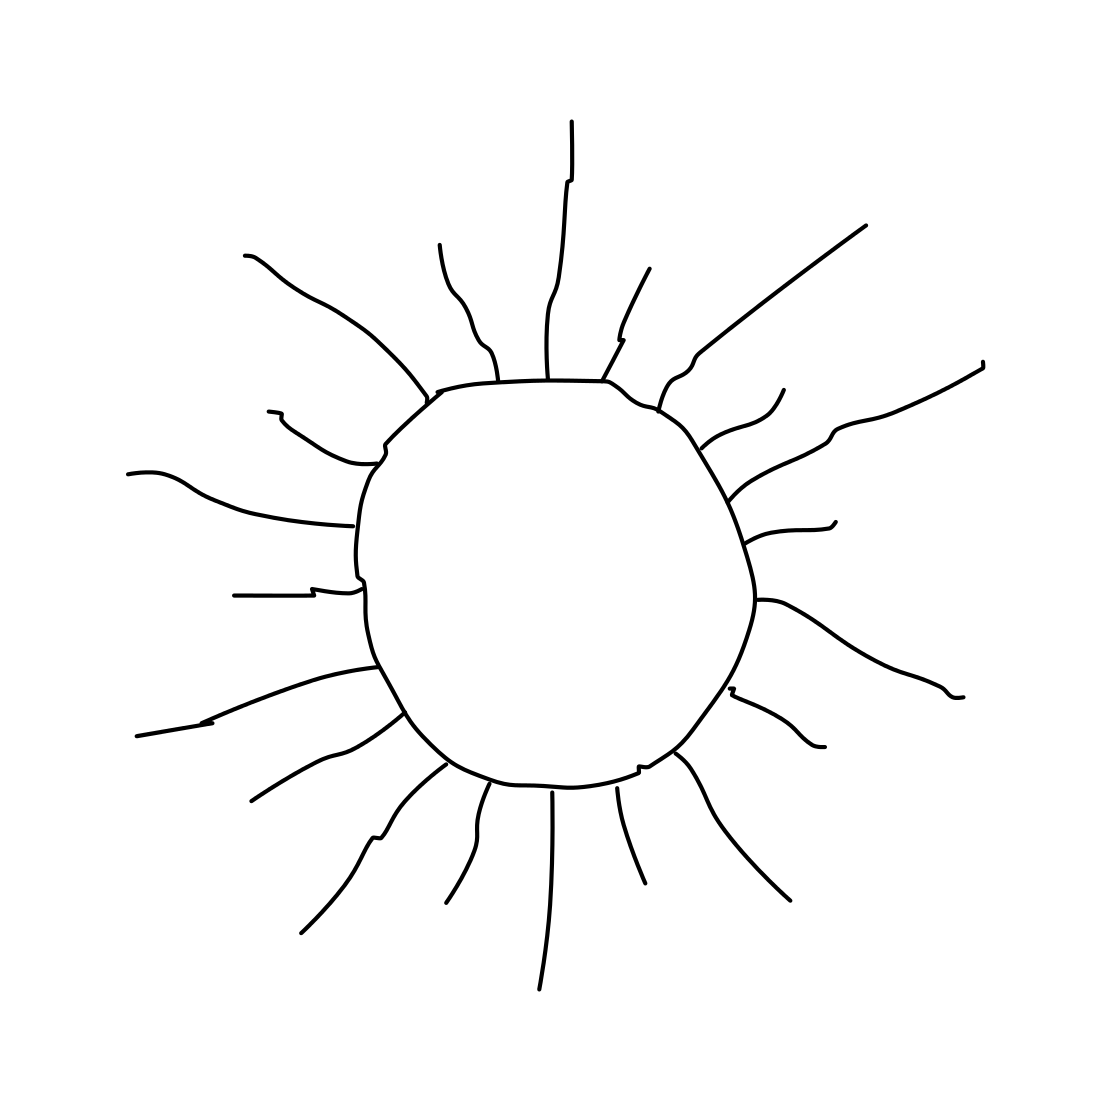What mood does the sun in this picture evoke? The prominent and clear depiction of the sun radiates a sense of warmth and positivity, often associated with happiness and optimism. 